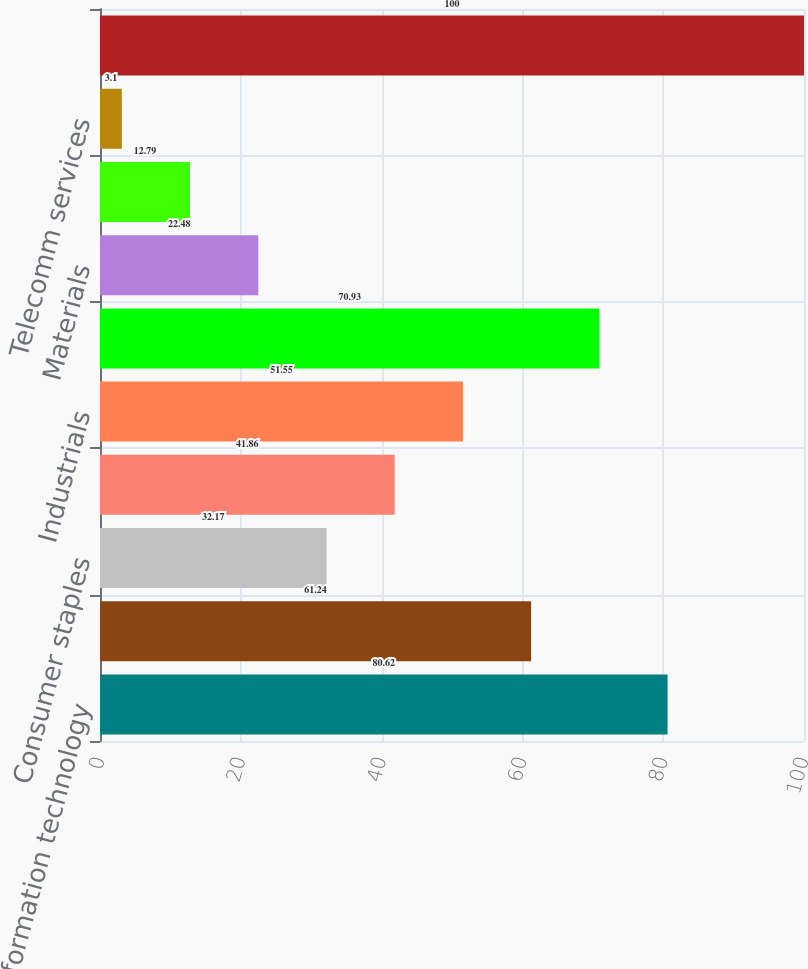<chart> <loc_0><loc_0><loc_500><loc_500><bar_chart><fcel>Information technology<fcel>Energy<fcel>Consumer staples<fcel>Healthcare<fcel>Industrials<fcel>Financial<fcel>Materials<fcel>Utilities<fcel>Telecomm services<fcel>Total<nl><fcel>80.62<fcel>61.24<fcel>32.17<fcel>41.86<fcel>51.55<fcel>70.93<fcel>22.48<fcel>12.79<fcel>3.1<fcel>100<nl></chart> 